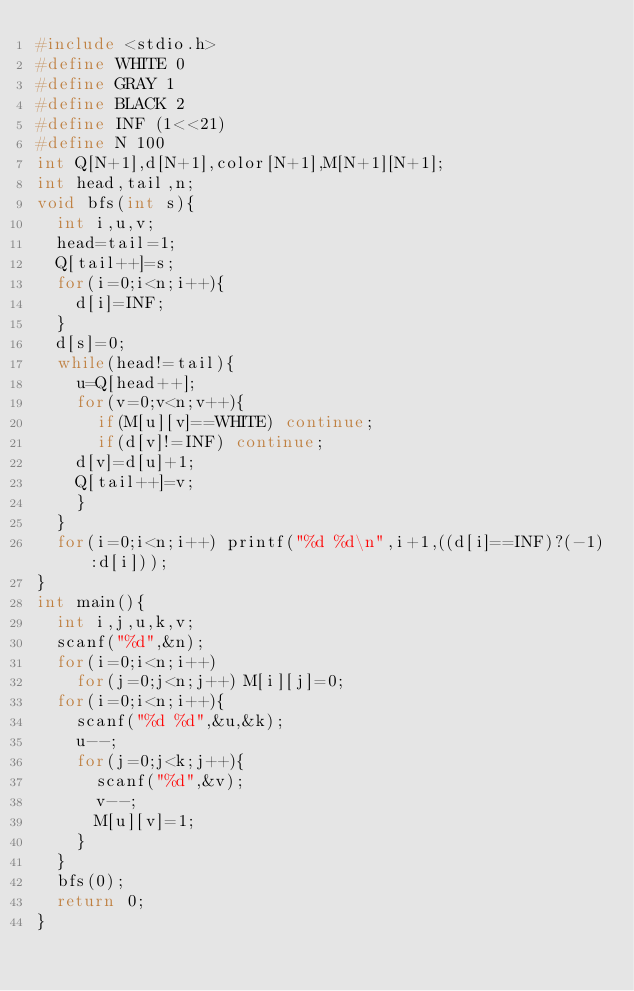<code> <loc_0><loc_0><loc_500><loc_500><_C_>#include <stdio.h>
#define WHITE 0
#define GRAY 1
#define BLACK 2
#define INF (1<<21)
#define N 100
int Q[N+1],d[N+1],color[N+1],M[N+1][N+1];
int head,tail,n;
void bfs(int s){
  int i,u,v;
  head=tail=1;
  Q[tail++]=s;
  for(i=0;i<n;i++){
    d[i]=INF;
  }
  d[s]=0;
  while(head!=tail){
    u=Q[head++];
    for(v=0;v<n;v++){
      if(M[u][v]==WHITE) continue;
      if(d[v]!=INF) continue;
    d[v]=d[u]+1;
    Q[tail++]=v;
    }
  }
  for(i=0;i<n;i++) printf("%d %d\n",i+1,((d[i]==INF)?(-1):d[i]));    
}
int main(){
  int i,j,u,k,v;
  scanf("%d",&n);
  for(i=0;i<n;i++)
    for(j=0;j<n;j++) M[i][j]=0;
  for(i=0;i<n;i++){
    scanf("%d %d",&u,&k);
    u--;
    for(j=0;j<k;j++){
      scanf("%d",&v);
      v--;
      M[u][v]=1;
    }
  }
  bfs(0);
  return 0;
}</code> 